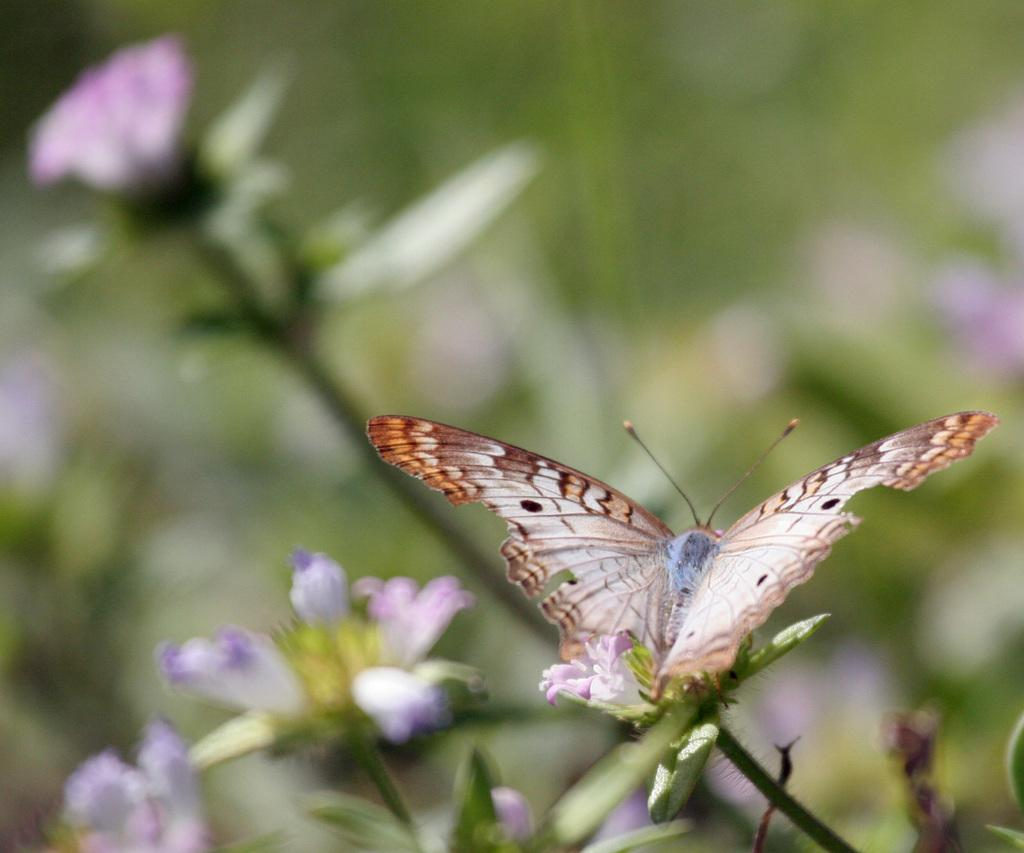What type of living organisms can be seen in the image? There are flowers and plants visible in the image. Can you describe any specific features of the plants? Yes, there is a butterfly on a stem in the image. How would you describe the overall appearance of the image? The background of the image is blurred. What time of day is depicted in the image? The provided facts do not mention the time of day, so it cannot be determined from the image. Is there a cave present in the image? There is no cave visible in the image. 